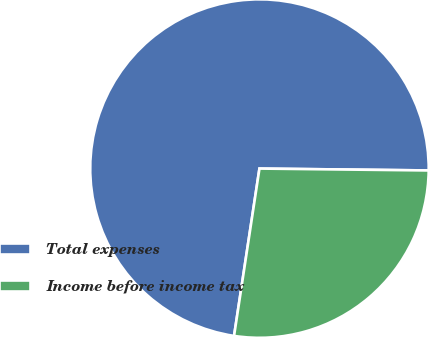<chart> <loc_0><loc_0><loc_500><loc_500><pie_chart><fcel>Total expenses<fcel>Income before income tax<nl><fcel>72.78%<fcel>27.22%<nl></chart> 